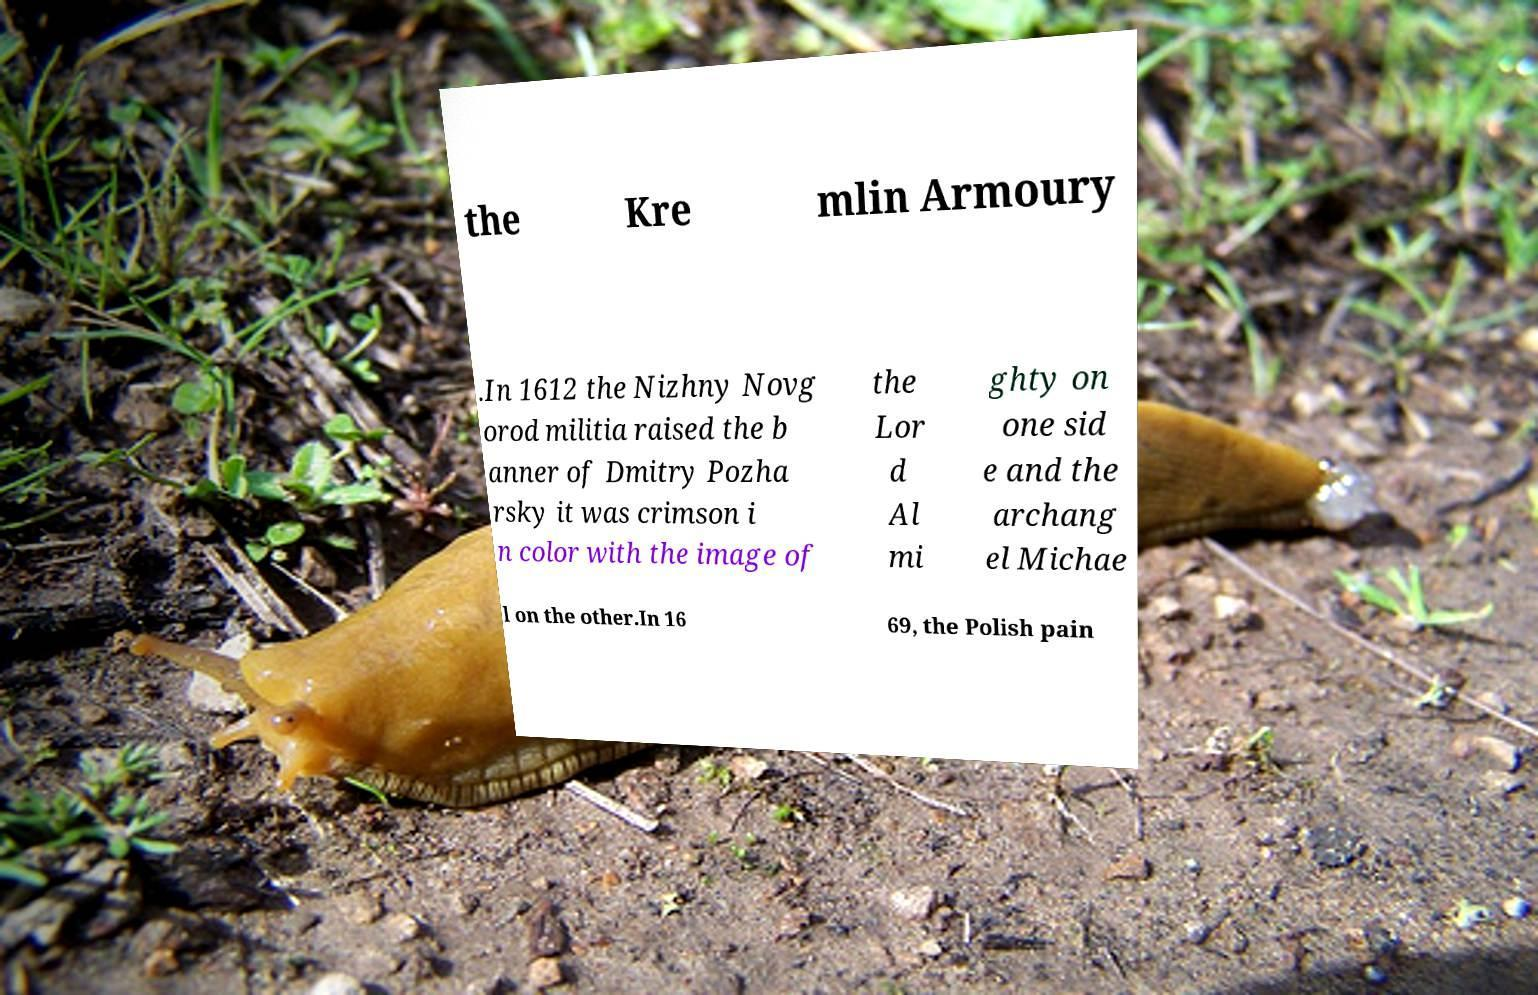Could you extract and type out the text from this image? the Kre mlin Armoury .In 1612 the Nizhny Novg orod militia raised the b anner of Dmitry Pozha rsky it was crimson i n color with the image of the Lor d Al mi ghty on one sid e and the archang el Michae l on the other.In 16 69, the Polish pain 